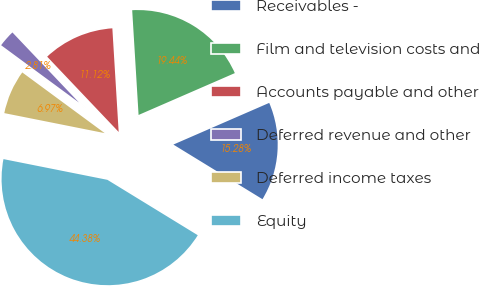Convert chart to OTSL. <chart><loc_0><loc_0><loc_500><loc_500><pie_chart><fcel>Receivables -<fcel>Film and television costs and<fcel>Accounts payable and other<fcel>Deferred revenue and other<fcel>Deferred income taxes<fcel>Equity<nl><fcel>15.28%<fcel>19.44%<fcel>11.12%<fcel>2.81%<fcel>6.97%<fcel>44.38%<nl></chart> 